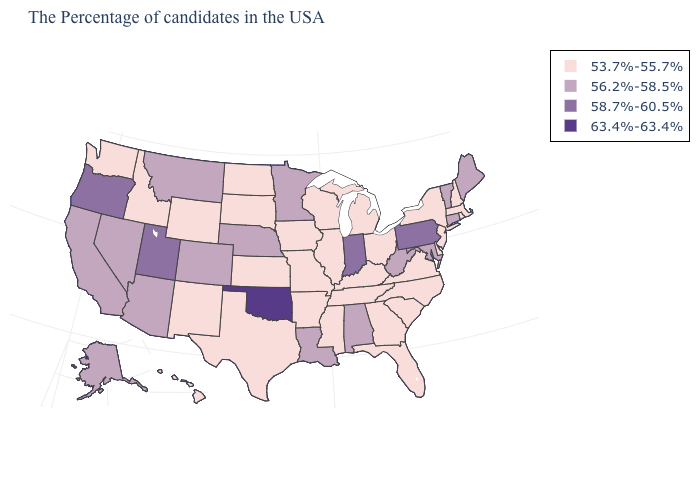Name the states that have a value in the range 56.2%-58.5%?
Concise answer only. Maine, Vermont, Connecticut, Maryland, West Virginia, Alabama, Louisiana, Minnesota, Nebraska, Colorado, Montana, Arizona, Nevada, California, Alaska. What is the value of Michigan?
Be succinct. 53.7%-55.7%. What is the value of Rhode Island?
Keep it brief. 53.7%-55.7%. What is the value of Wyoming?
Quick response, please. 53.7%-55.7%. Name the states that have a value in the range 56.2%-58.5%?
Concise answer only. Maine, Vermont, Connecticut, Maryland, West Virginia, Alabama, Louisiana, Minnesota, Nebraska, Colorado, Montana, Arizona, Nevada, California, Alaska. Which states have the lowest value in the USA?
Give a very brief answer. Massachusetts, Rhode Island, New Hampshire, New York, New Jersey, Delaware, Virginia, North Carolina, South Carolina, Ohio, Florida, Georgia, Michigan, Kentucky, Tennessee, Wisconsin, Illinois, Mississippi, Missouri, Arkansas, Iowa, Kansas, Texas, South Dakota, North Dakota, Wyoming, New Mexico, Idaho, Washington, Hawaii. What is the lowest value in the MidWest?
Concise answer only. 53.7%-55.7%. Does the first symbol in the legend represent the smallest category?
Be succinct. Yes. What is the value of Indiana?
Answer briefly. 58.7%-60.5%. Does Pennsylvania have the highest value in the Northeast?
Quick response, please. Yes. Name the states that have a value in the range 56.2%-58.5%?
Give a very brief answer. Maine, Vermont, Connecticut, Maryland, West Virginia, Alabama, Louisiana, Minnesota, Nebraska, Colorado, Montana, Arizona, Nevada, California, Alaska. What is the value of South Carolina?
Short answer required. 53.7%-55.7%. What is the value of Delaware?
Quick response, please. 53.7%-55.7%. What is the value of Wyoming?
Keep it brief. 53.7%-55.7%. What is the value of Colorado?
Short answer required. 56.2%-58.5%. 